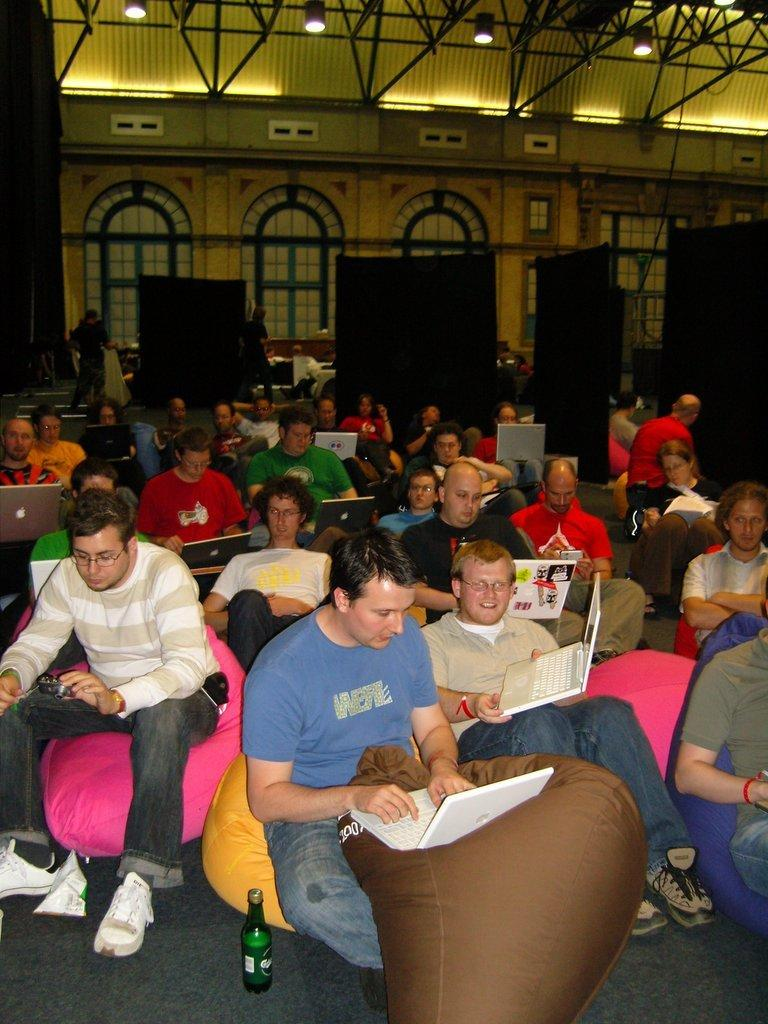What are the people in the foreground of the image doing? There are people sitting in the foreground of the image, and some of them are using laptops. What can be seen in the background of the image? In the background of the image, there are lamps, arches, and doors. What type of ornament is being worn by the person in the image? There is no specific ornament mentioned or visible in the image. What kind of apparel is the person wearing in the image? The provided facts do not mention any specific apparel worn by the people in the image. 